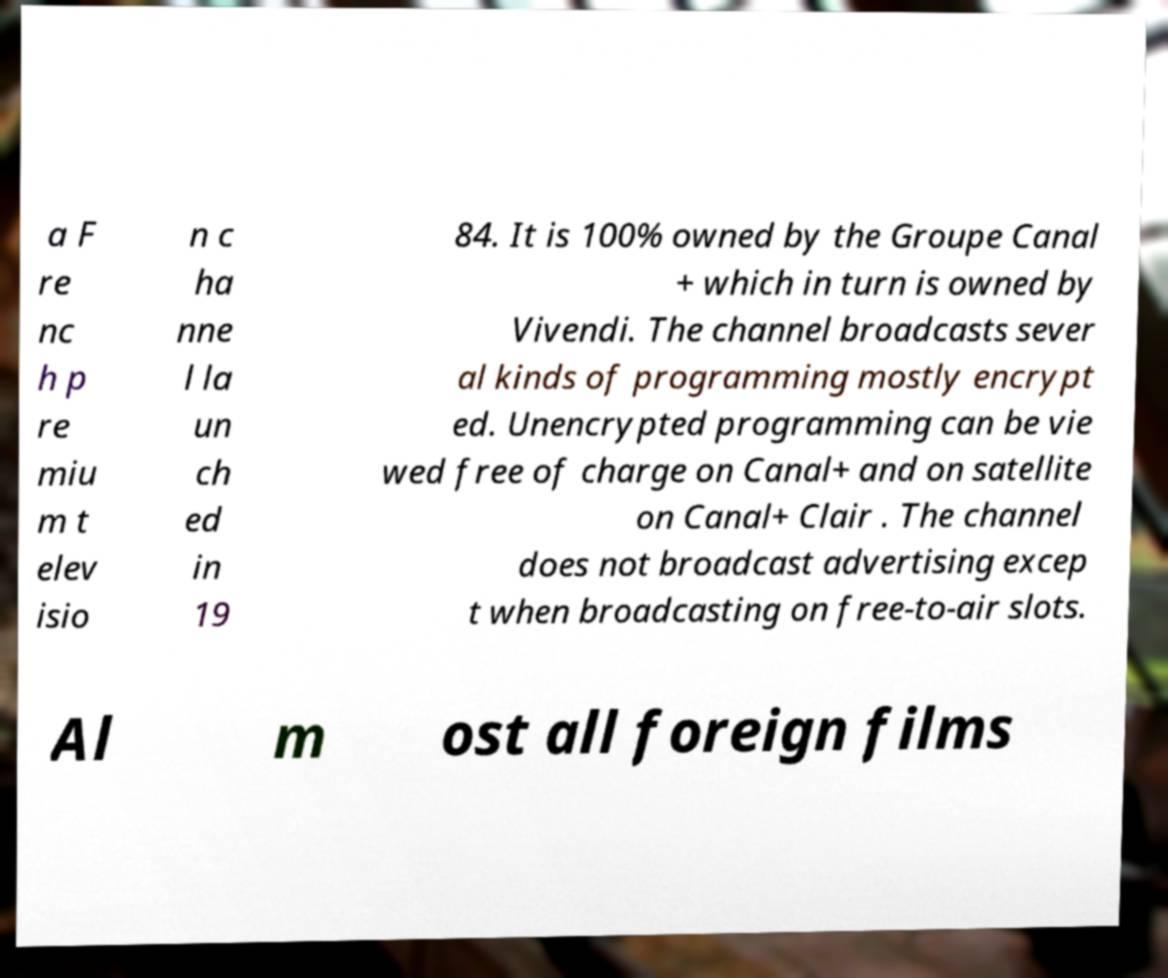Could you assist in decoding the text presented in this image and type it out clearly? a F re nc h p re miu m t elev isio n c ha nne l la un ch ed in 19 84. It is 100% owned by the Groupe Canal + which in turn is owned by Vivendi. The channel broadcasts sever al kinds of programming mostly encrypt ed. Unencrypted programming can be vie wed free of charge on Canal+ and on satellite on Canal+ Clair . The channel does not broadcast advertising excep t when broadcasting on free-to-air slots. Al m ost all foreign films 